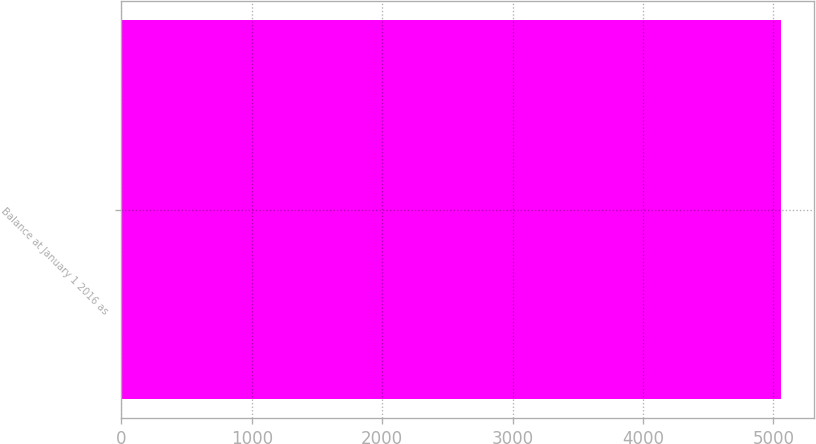Convert chart. <chart><loc_0><loc_0><loc_500><loc_500><bar_chart><fcel>Balance at January 1 2016 as<nl><fcel>5061.1<nl></chart> 